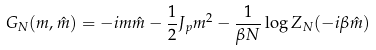Convert formula to latex. <formula><loc_0><loc_0><loc_500><loc_500>G _ { N } ( m , \hat { m } ) = - i m \hat { m } - \frac { 1 } { 2 } J _ { p } m ^ { 2 } - \frac { 1 } { \beta N } \log Z _ { N } ( - i \beta \hat { m } )</formula> 